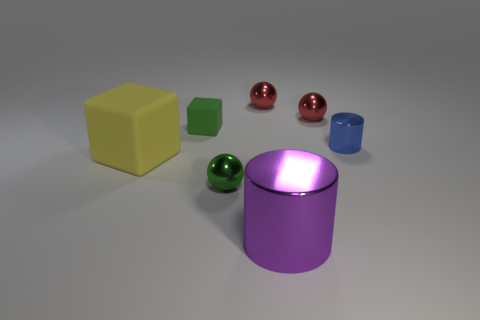How many other objects are there of the same size as the yellow rubber cube?
Your answer should be very brief. 1. What color is the small metal cylinder?
Your response must be concise. Blue. Are any metallic balls visible?
Provide a short and direct response. Yes. Are there any matte blocks in front of the yellow rubber block?
Provide a succinct answer. No. There is a tiny thing that is the same shape as the large purple shiny object; what is it made of?
Offer a very short reply. Metal. What number of other things are the same shape as the small green rubber thing?
Your response must be concise. 1. What number of tiny green matte blocks are to the left of the small red metallic object that is to the left of the cylinder in front of the yellow thing?
Provide a short and direct response. 1. What number of large purple metallic objects are the same shape as the yellow thing?
Your answer should be very brief. 0. There is a metallic sphere that is in front of the small matte object; is its color the same as the tiny cube?
Offer a terse response. Yes. There is a tiny red shiny object behind the small red metallic thing that is to the right of the red shiny sphere that is to the left of the big metallic thing; what is its shape?
Your answer should be very brief. Sphere. 